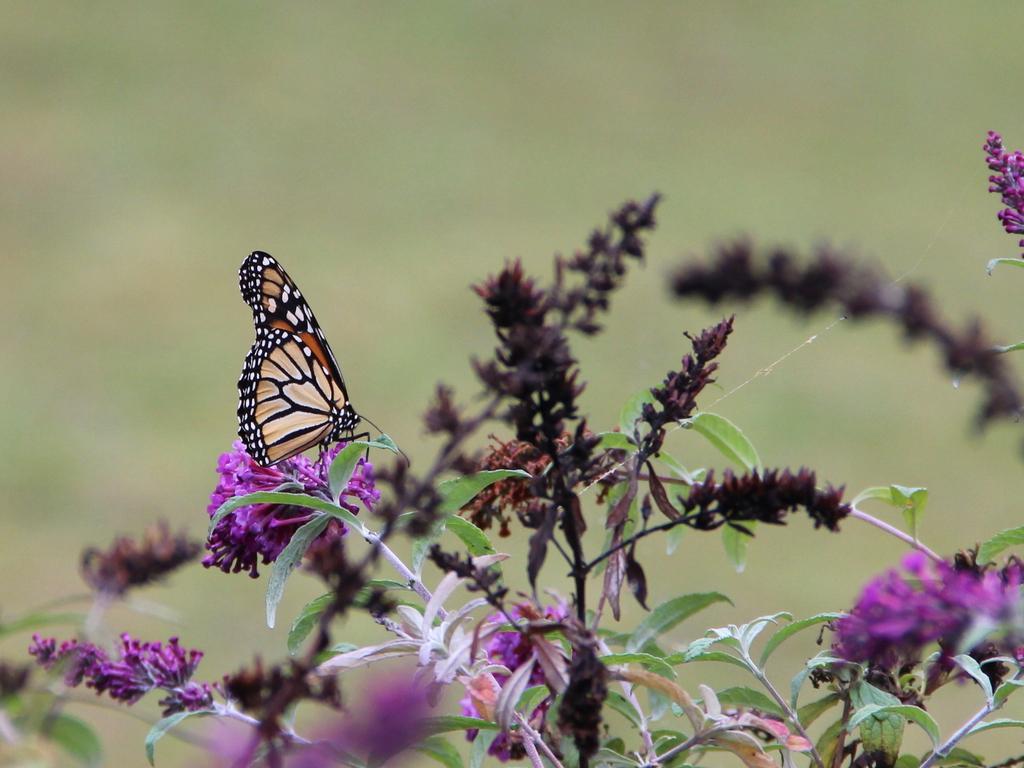Describe this image in one or two sentences. In this image we can see some flowers on the plants and also we can see a butterfly on the plant. 